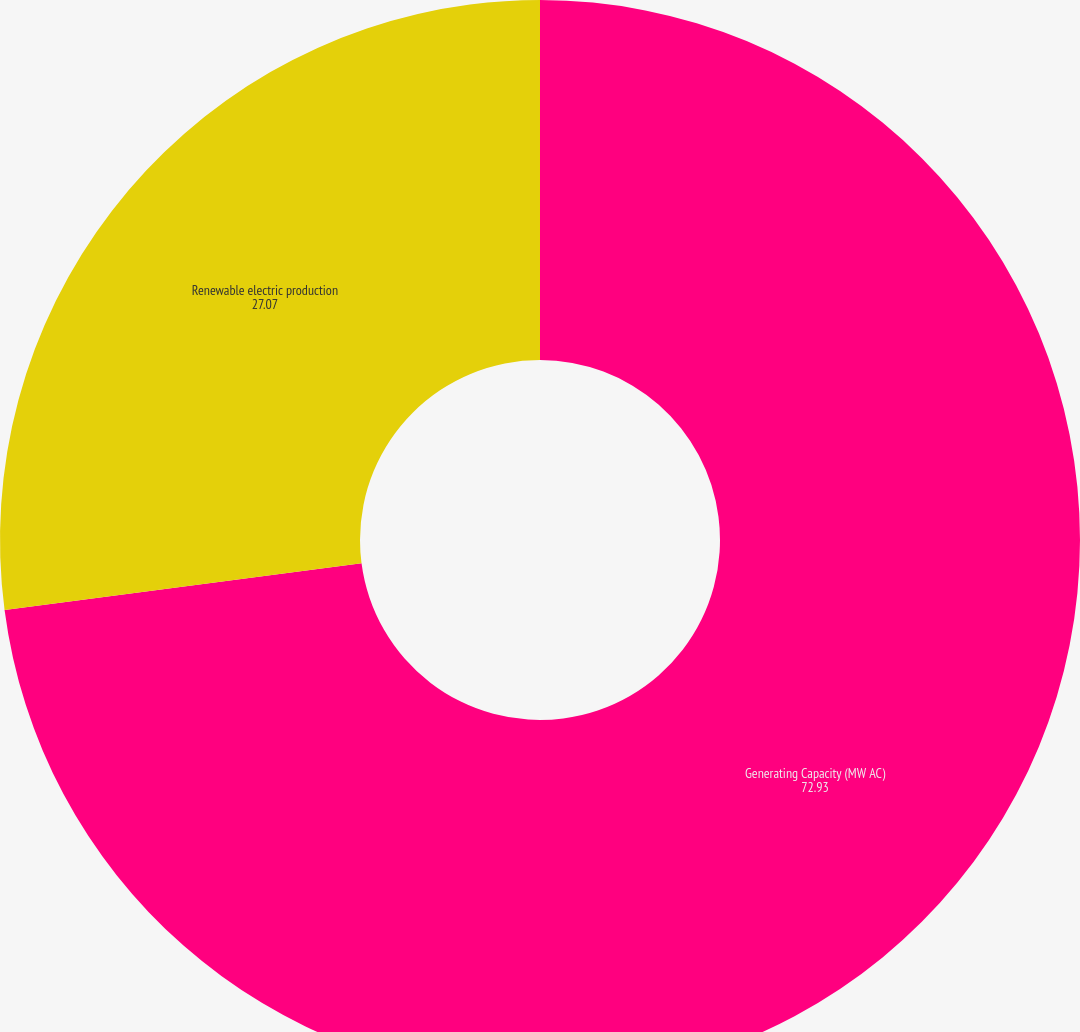<chart> <loc_0><loc_0><loc_500><loc_500><pie_chart><fcel>Generating Capacity (MW AC)<fcel>Renewable electric production<nl><fcel>72.93%<fcel>27.07%<nl></chart> 